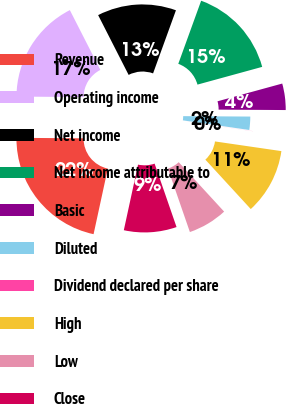Convert chart. <chart><loc_0><loc_0><loc_500><loc_500><pie_chart><fcel>Revenue<fcel>Operating income<fcel>Net income<fcel>Net income attributable to<fcel>Basic<fcel>Diluted<fcel>Dividend declared per share<fcel>High<fcel>Low<fcel>Close<nl><fcel>21.72%<fcel>17.38%<fcel>13.04%<fcel>15.21%<fcel>4.36%<fcel>2.19%<fcel>0.01%<fcel>10.87%<fcel>6.53%<fcel>8.7%<nl></chart> 